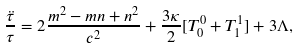Convert formula to latex. <formula><loc_0><loc_0><loc_500><loc_500>\frac { \ddot { \tau } } { \tau } = 2 \frac { m ^ { 2 } - m n + n ^ { 2 } } { c ^ { 2 } } + \frac { 3 \kappa } { 2 } [ T _ { 0 } ^ { 0 } + T _ { 1 } ^ { 1 } ] + 3 \Lambda ,</formula> 